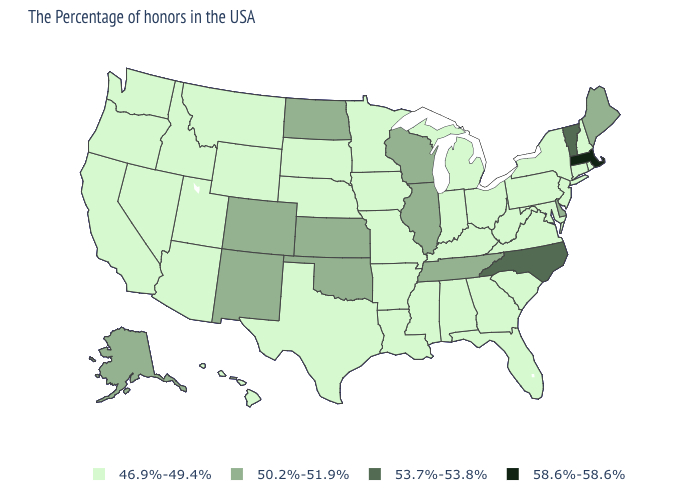Does Wisconsin have a higher value than Oregon?
Concise answer only. Yes. Does Florida have the lowest value in the USA?
Write a very short answer. Yes. What is the value of Hawaii?
Write a very short answer. 46.9%-49.4%. Name the states that have a value in the range 46.9%-49.4%?
Be succinct. Rhode Island, New Hampshire, Connecticut, New York, New Jersey, Maryland, Pennsylvania, Virginia, South Carolina, West Virginia, Ohio, Florida, Georgia, Michigan, Kentucky, Indiana, Alabama, Mississippi, Louisiana, Missouri, Arkansas, Minnesota, Iowa, Nebraska, Texas, South Dakota, Wyoming, Utah, Montana, Arizona, Idaho, Nevada, California, Washington, Oregon, Hawaii. What is the value of Alaska?
Keep it brief. 50.2%-51.9%. What is the highest value in the Northeast ?
Short answer required. 58.6%-58.6%. What is the value of Minnesota?
Be succinct. 46.9%-49.4%. What is the value of Washington?
Give a very brief answer. 46.9%-49.4%. Among the states that border North Carolina , which have the lowest value?
Answer briefly. Virginia, South Carolina, Georgia. Which states have the lowest value in the USA?
Short answer required. Rhode Island, New Hampshire, Connecticut, New York, New Jersey, Maryland, Pennsylvania, Virginia, South Carolina, West Virginia, Ohio, Florida, Georgia, Michigan, Kentucky, Indiana, Alabama, Mississippi, Louisiana, Missouri, Arkansas, Minnesota, Iowa, Nebraska, Texas, South Dakota, Wyoming, Utah, Montana, Arizona, Idaho, Nevada, California, Washington, Oregon, Hawaii. How many symbols are there in the legend?
Write a very short answer. 4. Does Maine have the highest value in the Northeast?
Concise answer only. No. Name the states that have a value in the range 50.2%-51.9%?
Give a very brief answer. Maine, Delaware, Tennessee, Wisconsin, Illinois, Kansas, Oklahoma, North Dakota, Colorado, New Mexico, Alaska. Name the states that have a value in the range 46.9%-49.4%?
Answer briefly. Rhode Island, New Hampshire, Connecticut, New York, New Jersey, Maryland, Pennsylvania, Virginia, South Carolina, West Virginia, Ohio, Florida, Georgia, Michigan, Kentucky, Indiana, Alabama, Mississippi, Louisiana, Missouri, Arkansas, Minnesota, Iowa, Nebraska, Texas, South Dakota, Wyoming, Utah, Montana, Arizona, Idaho, Nevada, California, Washington, Oregon, Hawaii. What is the value of Oregon?
Write a very short answer. 46.9%-49.4%. 